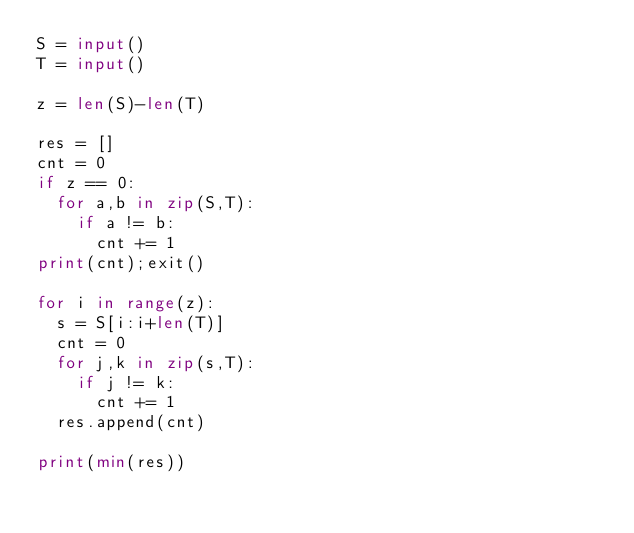Convert code to text. <code><loc_0><loc_0><loc_500><loc_500><_Python_>S = input()
T = input()

z = len(S)-len(T)

res = []
cnt = 0
if z == 0:
  for a,b in zip(S,T):
    if a != b:
      cnt += 1
print(cnt);exit()
    
for i in range(z):
  s = S[i:i+len(T)]
  cnt = 0
  for j,k in zip(s,T):
    if j != k:
      cnt += 1
  res.append(cnt)

print(min(res))</code> 